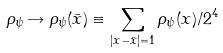<formula> <loc_0><loc_0><loc_500><loc_500>\rho _ { \psi } \rightarrow \rho _ { \psi } ( \bar { x } ) \equiv \sum _ { | x - \bar { x } | = 1 } \rho _ { \psi } ( x ) / 2 ^ { 4 }</formula> 